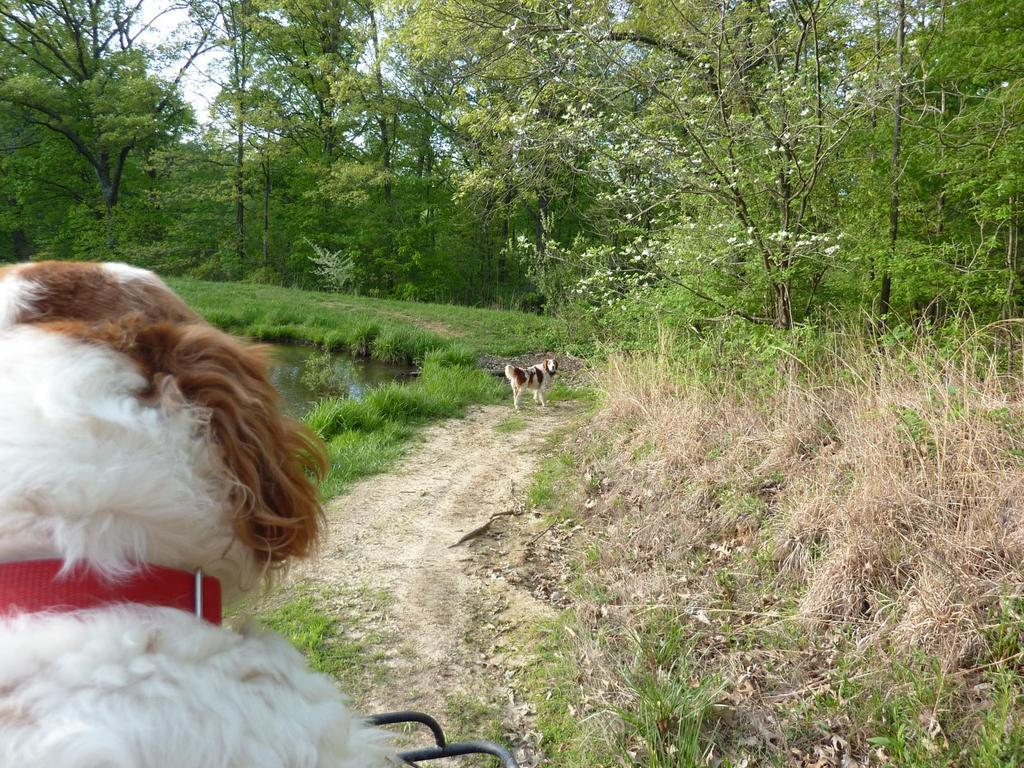How many dogs are present in the image? There are two dogs in the image. What type of terrain is visible in the image? There is grass, plants, and trees in the image. Is there any body of water in the image? Yes, there is a pond in the image. What type of drink is the boy holding in the image? There is no boy present in the image, so it is not possible to determine what type of drink might be held. 